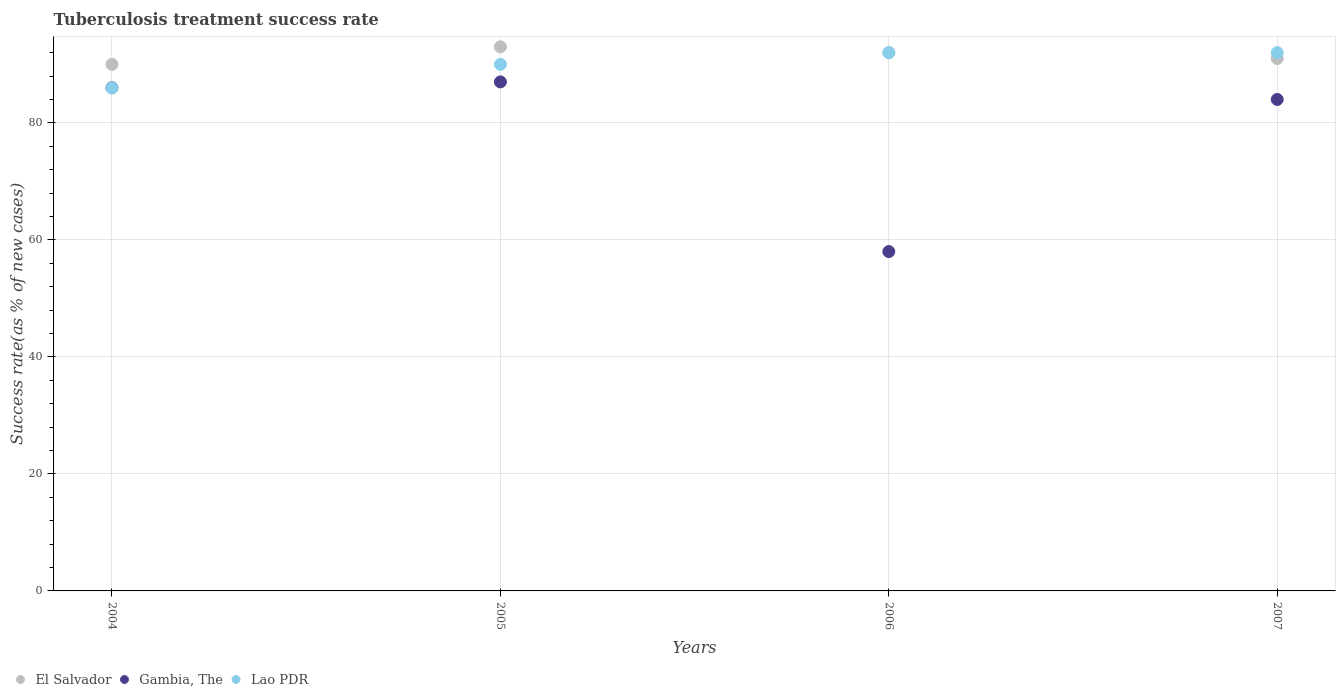Is the number of dotlines equal to the number of legend labels?
Offer a very short reply. Yes. What is the tuberculosis treatment success rate in Lao PDR in 2006?
Your answer should be very brief. 92. Across all years, what is the maximum tuberculosis treatment success rate in Lao PDR?
Your answer should be very brief. 92. Across all years, what is the minimum tuberculosis treatment success rate in El Salvador?
Offer a very short reply. 90. In which year was the tuberculosis treatment success rate in El Salvador maximum?
Make the answer very short. 2005. What is the total tuberculosis treatment success rate in Gambia, The in the graph?
Give a very brief answer. 315. What is the difference between the tuberculosis treatment success rate in Lao PDR in 2004 and that in 2007?
Make the answer very short. -6. What is the difference between the tuberculosis treatment success rate in Lao PDR in 2006 and the tuberculosis treatment success rate in Gambia, The in 2004?
Offer a very short reply. 6. In the year 2004, what is the difference between the tuberculosis treatment success rate in El Salvador and tuberculosis treatment success rate in Gambia, The?
Ensure brevity in your answer.  4. In how many years, is the tuberculosis treatment success rate in Lao PDR greater than 16 %?
Make the answer very short. 4. What is the ratio of the tuberculosis treatment success rate in Lao PDR in 2004 to that in 2006?
Your response must be concise. 0.93. What is the difference between the highest and the second highest tuberculosis treatment success rate in Gambia, The?
Your answer should be compact. 1. What is the difference between the highest and the lowest tuberculosis treatment success rate in El Salvador?
Ensure brevity in your answer.  3. Is it the case that in every year, the sum of the tuberculosis treatment success rate in El Salvador and tuberculosis treatment success rate in Gambia, The  is greater than the tuberculosis treatment success rate in Lao PDR?
Give a very brief answer. Yes. Is the tuberculosis treatment success rate in Lao PDR strictly less than the tuberculosis treatment success rate in El Salvador over the years?
Provide a succinct answer. No. What is the difference between two consecutive major ticks on the Y-axis?
Your answer should be compact. 20. Does the graph contain any zero values?
Your answer should be very brief. No. How are the legend labels stacked?
Give a very brief answer. Horizontal. What is the title of the graph?
Ensure brevity in your answer.  Tuberculosis treatment success rate. What is the label or title of the Y-axis?
Ensure brevity in your answer.  Success rate(as % of new cases). What is the Success rate(as % of new cases) of El Salvador in 2004?
Your response must be concise. 90. What is the Success rate(as % of new cases) of El Salvador in 2005?
Give a very brief answer. 93. What is the Success rate(as % of new cases) in Gambia, The in 2005?
Provide a short and direct response. 87. What is the Success rate(as % of new cases) in Lao PDR in 2005?
Your response must be concise. 90. What is the Success rate(as % of new cases) in El Salvador in 2006?
Your answer should be compact. 92. What is the Success rate(as % of new cases) of Gambia, The in 2006?
Provide a short and direct response. 58. What is the Success rate(as % of new cases) in Lao PDR in 2006?
Provide a short and direct response. 92. What is the Success rate(as % of new cases) of El Salvador in 2007?
Offer a very short reply. 91. What is the Success rate(as % of new cases) of Lao PDR in 2007?
Keep it short and to the point. 92. Across all years, what is the maximum Success rate(as % of new cases) in El Salvador?
Offer a very short reply. 93. Across all years, what is the maximum Success rate(as % of new cases) in Gambia, The?
Provide a succinct answer. 87. Across all years, what is the maximum Success rate(as % of new cases) of Lao PDR?
Keep it short and to the point. 92. Across all years, what is the minimum Success rate(as % of new cases) of El Salvador?
Provide a short and direct response. 90. What is the total Success rate(as % of new cases) of El Salvador in the graph?
Make the answer very short. 366. What is the total Success rate(as % of new cases) of Gambia, The in the graph?
Provide a succinct answer. 315. What is the total Success rate(as % of new cases) in Lao PDR in the graph?
Your answer should be very brief. 360. What is the difference between the Success rate(as % of new cases) in El Salvador in 2004 and that in 2005?
Offer a very short reply. -3. What is the difference between the Success rate(as % of new cases) of Gambia, The in 2004 and that in 2005?
Provide a short and direct response. -1. What is the difference between the Success rate(as % of new cases) of Lao PDR in 2004 and that in 2005?
Provide a short and direct response. -4. What is the difference between the Success rate(as % of new cases) in Gambia, The in 2004 and that in 2006?
Offer a terse response. 28. What is the difference between the Success rate(as % of new cases) in Lao PDR in 2005 and that in 2006?
Make the answer very short. -2. What is the difference between the Success rate(as % of new cases) of El Salvador in 2005 and that in 2007?
Provide a short and direct response. 2. What is the difference between the Success rate(as % of new cases) in Lao PDR in 2005 and that in 2007?
Provide a succinct answer. -2. What is the difference between the Success rate(as % of new cases) of El Salvador in 2006 and that in 2007?
Provide a succinct answer. 1. What is the difference between the Success rate(as % of new cases) of El Salvador in 2004 and the Success rate(as % of new cases) of Gambia, The in 2005?
Offer a very short reply. 3. What is the difference between the Success rate(as % of new cases) of El Salvador in 2004 and the Success rate(as % of new cases) of Lao PDR in 2006?
Make the answer very short. -2. What is the difference between the Success rate(as % of new cases) of Gambia, The in 2004 and the Success rate(as % of new cases) of Lao PDR in 2006?
Keep it short and to the point. -6. What is the difference between the Success rate(as % of new cases) in El Salvador in 2004 and the Success rate(as % of new cases) in Lao PDR in 2007?
Your answer should be compact. -2. What is the difference between the Success rate(as % of new cases) of Gambia, The in 2004 and the Success rate(as % of new cases) of Lao PDR in 2007?
Your answer should be compact. -6. What is the difference between the Success rate(as % of new cases) of El Salvador in 2005 and the Success rate(as % of new cases) of Gambia, The in 2006?
Make the answer very short. 35. What is the difference between the Success rate(as % of new cases) of El Salvador in 2006 and the Success rate(as % of new cases) of Gambia, The in 2007?
Offer a very short reply. 8. What is the difference between the Success rate(as % of new cases) in Gambia, The in 2006 and the Success rate(as % of new cases) in Lao PDR in 2007?
Your answer should be very brief. -34. What is the average Success rate(as % of new cases) of El Salvador per year?
Keep it short and to the point. 91.5. What is the average Success rate(as % of new cases) in Gambia, The per year?
Provide a succinct answer. 78.75. In the year 2004, what is the difference between the Success rate(as % of new cases) in El Salvador and Success rate(as % of new cases) in Gambia, The?
Your response must be concise. 4. In the year 2004, what is the difference between the Success rate(as % of new cases) in El Salvador and Success rate(as % of new cases) in Lao PDR?
Give a very brief answer. 4. In the year 2005, what is the difference between the Success rate(as % of new cases) in Gambia, The and Success rate(as % of new cases) in Lao PDR?
Provide a short and direct response. -3. In the year 2006, what is the difference between the Success rate(as % of new cases) of Gambia, The and Success rate(as % of new cases) of Lao PDR?
Your answer should be compact. -34. In the year 2007, what is the difference between the Success rate(as % of new cases) in El Salvador and Success rate(as % of new cases) in Gambia, The?
Offer a very short reply. 7. What is the ratio of the Success rate(as % of new cases) in Gambia, The in 2004 to that in 2005?
Ensure brevity in your answer.  0.99. What is the ratio of the Success rate(as % of new cases) of Lao PDR in 2004 to that in 2005?
Your answer should be compact. 0.96. What is the ratio of the Success rate(as % of new cases) in El Salvador in 2004 to that in 2006?
Provide a succinct answer. 0.98. What is the ratio of the Success rate(as % of new cases) of Gambia, The in 2004 to that in 2006?
Ensure brevity in your answer.  1.48. What is the ratio of the Success rate(as % of new cases) in Lao PDR in 2004 to that in 2006?
Your answer should be very brief. 0.93. What is the ratio of the Success rate(as % of new cases) in El Salvador in 2004 to that in 2007?
Provide a succinct answer. 0.99. What is the ratio of the Success rate(as % of new cases) in Gambia, The in 2004 to that in 2007?
Offer a very short reply. 1.02. What is the ratio of the Success rate(as % of new cases) of Lao PDR in 2004 to that in 2007?
Your answer should be very brief. 0.93. What is the ratio of the Success rate(as % of new cases) of El Salvador in 2005 to that in 2006?
Ensure brevity in your answer.  1.01. What is the ratio of the Success rate(as % of new cases) of Lao PDR in 2005 to that in 2006?
Your answer should be very brief. 0.98. What is the ratio of the Success rate(as % of new cases) in El Salvador in 2005 to that in 2007?
Offer a terse response. 1.02. What is the ratio of the Success rate(as % of new cases) of Gambia, The in 2005 to that in 2007?
Offer a terse response. 1.04. What is the ratio of the Success rate(as % of new cases) in Lao PDR in 2005 to that in 2007?
Offer a terse response. 0.98. What is the ratio of the Success rate(as % of new cases) of Gambia, The in 2006 to that in 2007?
Offer a terse response. 0.69. What is the difference between the highest and the second highest Success rate(as % of new cases) in Gambia, The?
Keep it short and to the point. 1. What is the difference between the highest and the second highest Success rate(as % of new cases) in Lao PDR?
Give a very brief answer. 0. What is the difference between the highest and the lowest Success rate(as % of new cases) of Gambia, The?
Keep it short and to the point. 29. 